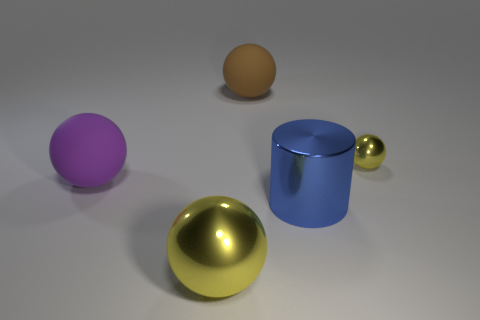Subtract all cylinders. How many objects are left? 4 Add 5 large cylinders. How many objects exist? 10 Add 1 tiny yellow spheres. How many tiny yellow spheres are left? 2 Add 4 purple rubber objects. How many purple rubber objects exist? 5 Subtract 0 green balls. How many objects are left? 5 Subtract all purple matte spheres. Subtract all yellow metal objects. How many objects are left? 2 